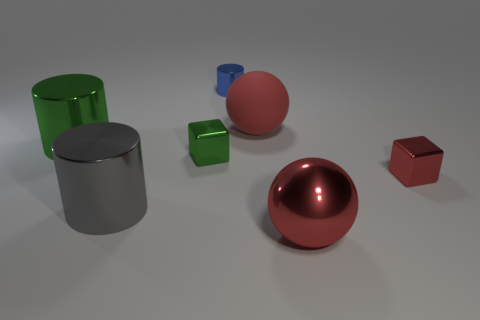There is a tiny block that is the same color as the rubber ball; what is its material?
Keep it short and to the point. Metal. What number of shiny things are either cubes or small green objects?
Make the answer very short. 2. The red matte object is what shape?
Provide a succinct answer. Sphere. How many tiny red objects are made of the same material as the red cube?
Provide a short and direct response. 0. What color is the ball that is the same material as the small cylinder?
Your answer should be very brief. Red. There is a metallic cube left of the blue shiny object; does it have the same size as the small metal cylinder?
Make the answer very short. Yes. There is a tiny metal object that is the same shape as the big green metallic object; what color is it?
Provide a short and direct response. Blue. What shape is the large red object in front of the small thing right of the big ball in front of the small red metal object?
Keep it short and to the point. Sphere. Is the shape of the big red metal thing the same as the big green metallic thing?
Give a very brief answer. No. The small object behind the tiny metallic thing that is on the left side of the tiny blue metallic thing is what shape?
Your response must be concise. Cylinder. 